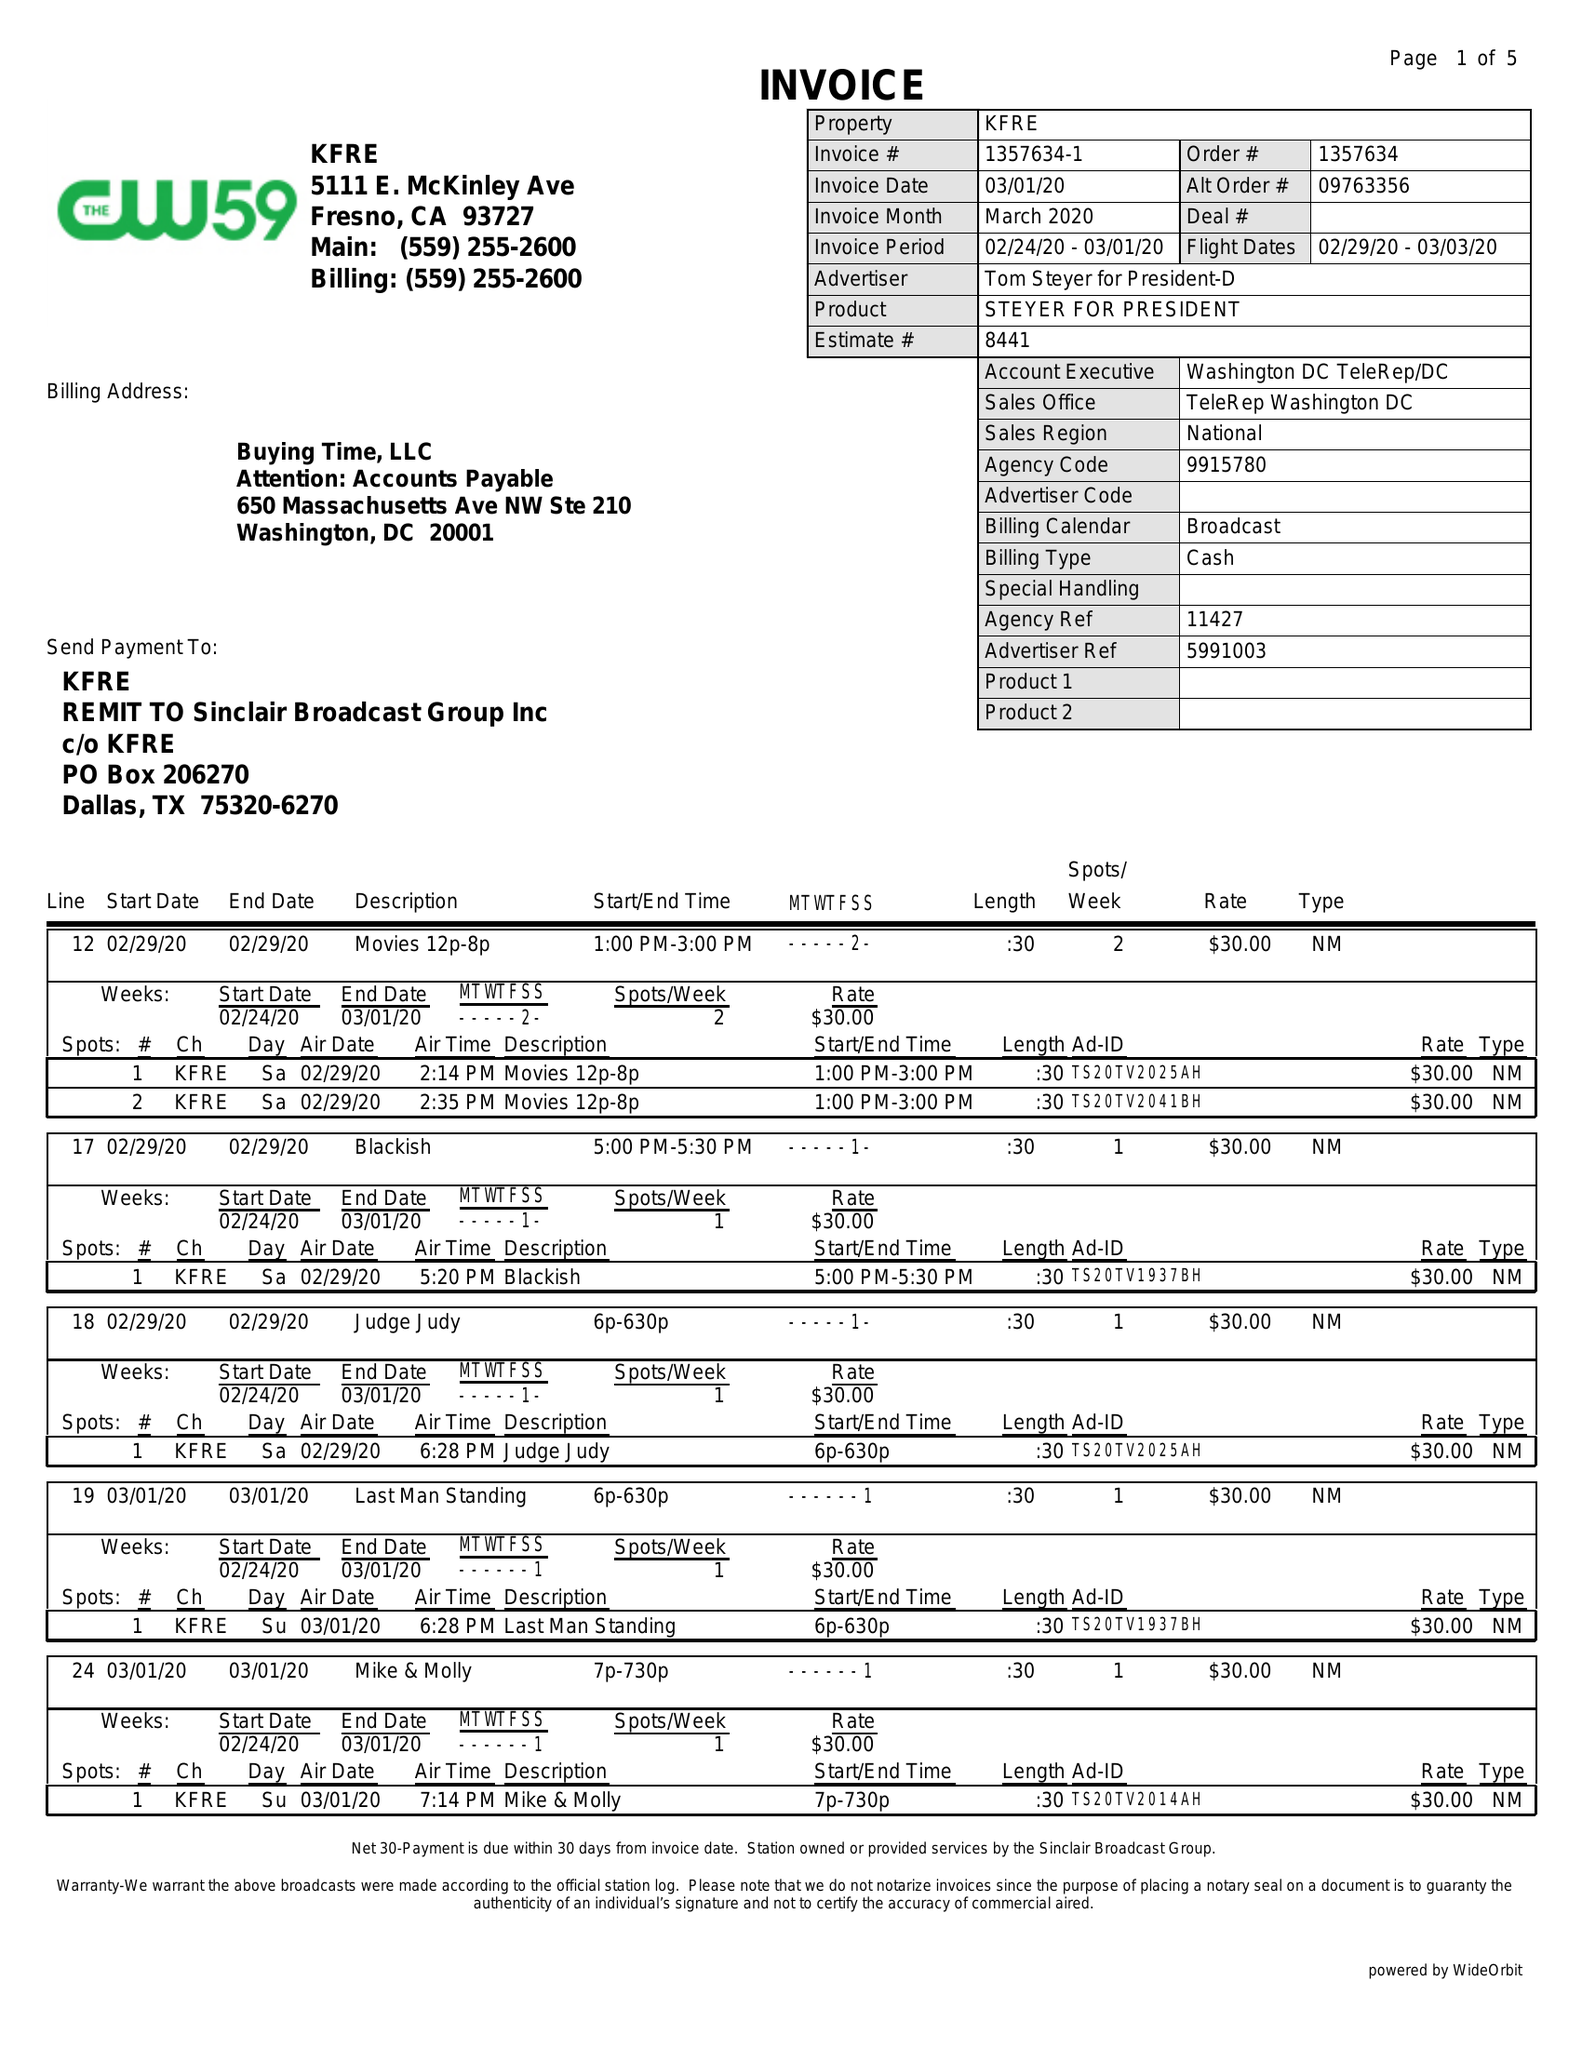What is the value for the flight_to?
Answer the question using a single word or phrase. 03/03/20 